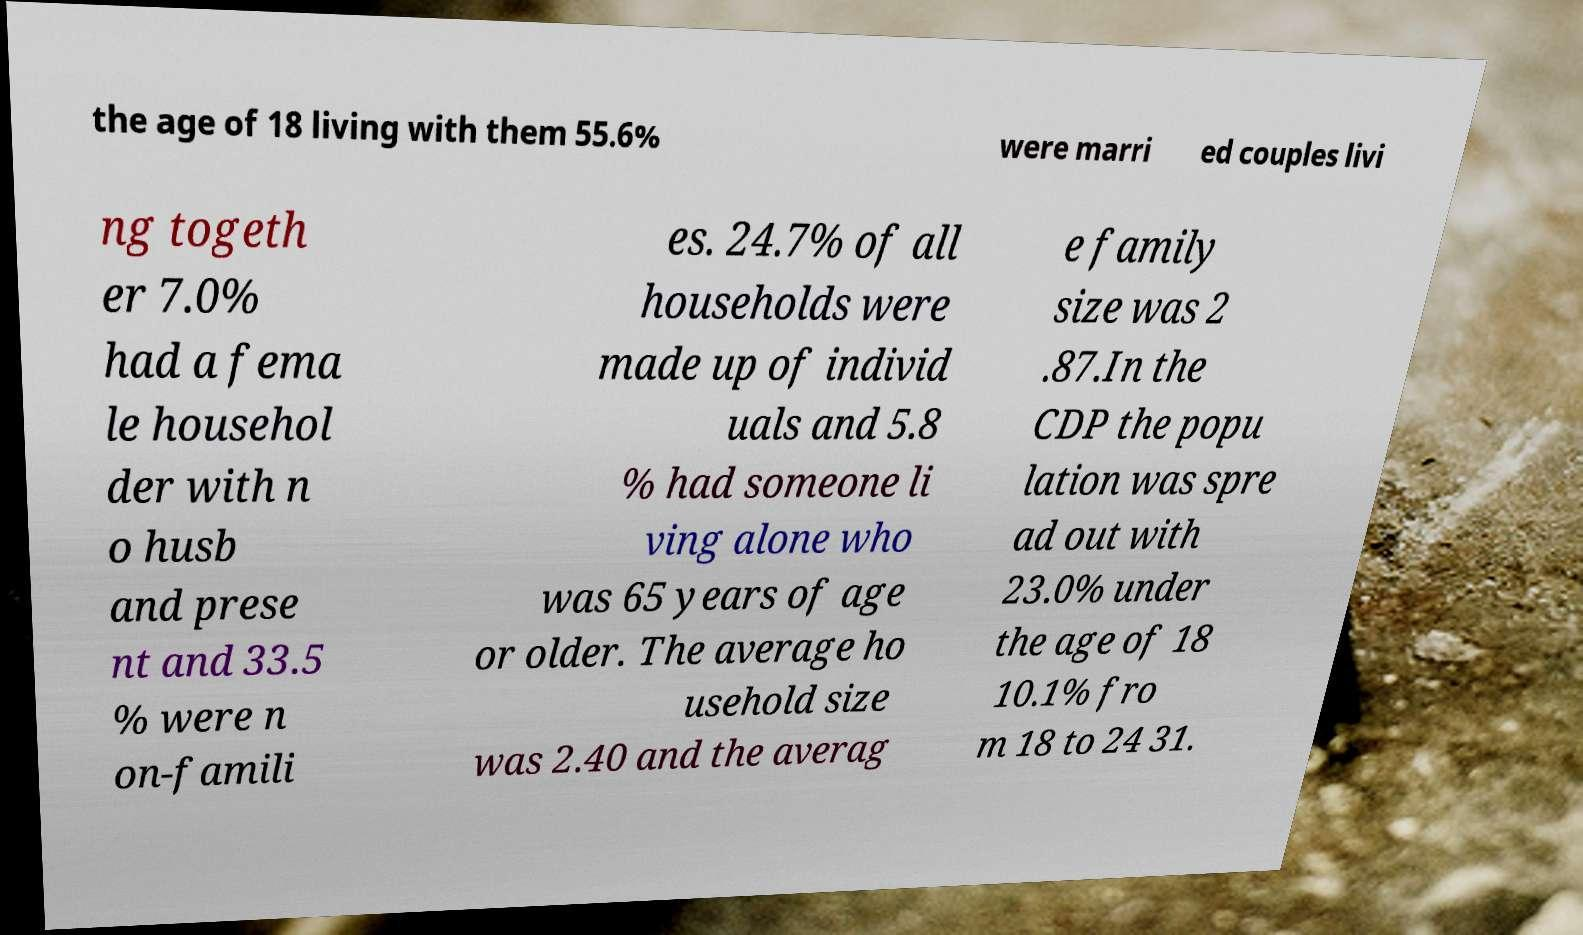I need the written content from this picture converted into text. Can you do that? the age of 18 living with them 55.6% were marri ed couples livi ng togeth er 7.0% had a fema le househol der with n o husb and prese nt and 33.5 % were n on-famili es. 24.7% of all households were made up of individ uals and 5.8 % had someone li ving alone who was 65 years of age or older. The average ho usehold size was 2.40 and the averag e family size was 2 .87.In the CDP the popu lation was spre ad out with 23.0% under the age of 18 10.1% fro m 18 to 24 31. 